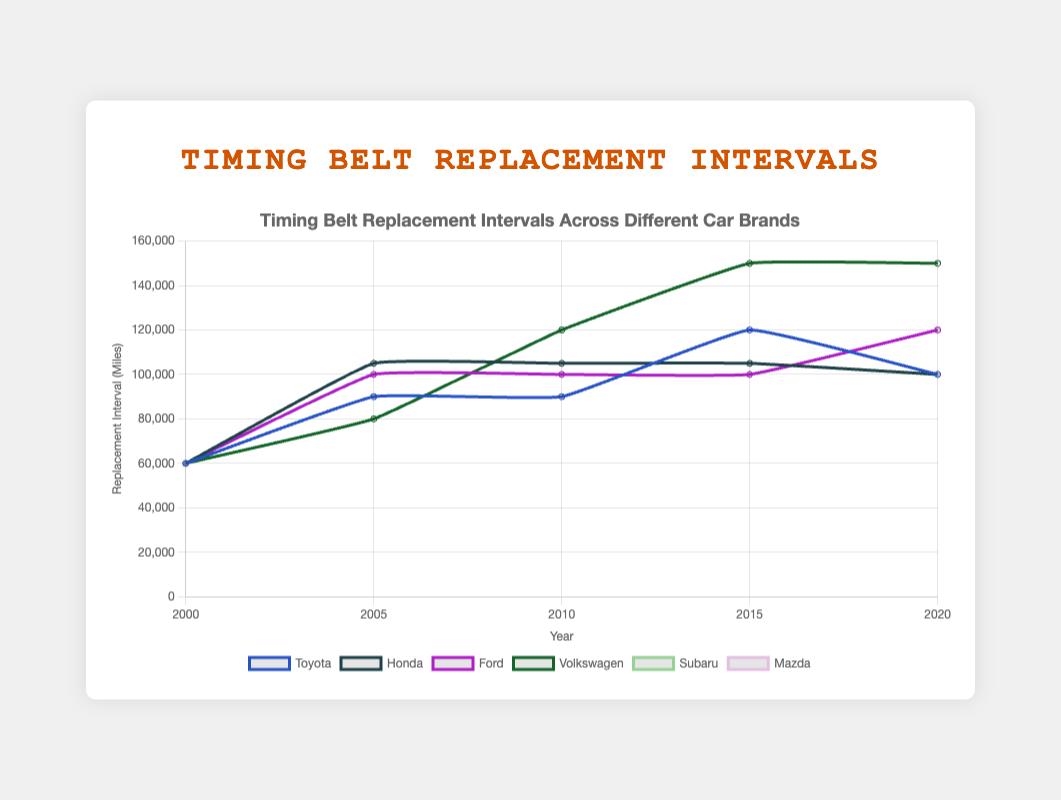Which car brand has the highest timing belt replacement interval in 2020? Looking at the graph, we find the 2020 data point for each brand. Volkswagen has the highest replacement interval of 150,000 miles.
Answer: Volkswagen Between 2000 and 2020, which car brand had the greatest overall improvement in timing belt replacement intervals? To find the greatest improvement, we calculate the difference for each brand between 2020 and 2000. Volkswagen improved from 60,000 to 150,000 miles, which is an increase of 90,000 miles, the highest among all brands.
Answer: Volkswagen In 2005, which car brands have the same timing belt replacement interval? Checking the 2005 data points, Toyota and Honda both have an interval of 90,000 miles.
Answer: Toyota and Honda What is the average timing belt replacement interval in 2015 for all car brands? We sum up the 2015 data points for all car brands (120,000 + 105,000 + 100,000 + 150,000 + 105,000 + 100,000 = 680,000) and divide by the number of brands (6). The average is 680,000 / 6 = 113,333 miles.
Answer: 113,333 miles Which car brand showed no change in timing belt replacement intervals from 2010 to 2020? Honda and Subaru maintained the same intervals of 105,000 miles (Honda) and 100,000 miles (Subaru) from 2010 to 2020.
Answer: Honda and Subaru What is the visual color used for Toyota on the graph? By examining the legend next to the lines, Toyota is represented with its unique assigned color.
Answer: Color specific to Toyota What is the difference in the timing belt replacement intervals between Mazda and Ford in 2020? In 2020, Mazda has 120,000 miles, and Ford has 120,000 miles. The difference is 120,000 - 120,000 = 0 miles.
Answer: 0 miles How many car brands have a timing belt replacement interval greater than or equal to 100,000 miles in 2020? Checking the 2020 data points, Honda, Ford, Volkswagen, Subaru, and Mazda all have intervals >= 100,000 miles. This makes 5 brands.
Answer: 5 brands Between 2010 and 2015, which car brand had the largest increase in timing belt replacement interval? Calculating the difference between 2010 and 2015 for each brand, Toyota had an increase of 30,000 miles (from 90,000 to 120,000). Volkswagen increased the most by 30,000 miles (from 120,000 to 150,000).
Answer: Volkswagen 